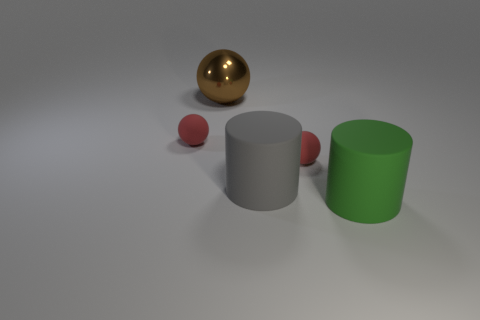What shape is the thing that is both left of the gray cylinder and in front of the brown metallic ball?
Ensure brevity in your answer.  Sphere. What is the material of the small object that is left of the big cylinder that is on the left side of the big green rubber cylinder?
Offer a very short reply. Rubber. Are the tiny object to the right of the metal thing and the big brown ball made of the same material?
Give a very brief answer. No. How big is the red thing right of the large brown sphere?
Your answer should be compact. Small. There is a red sphere to the left of the large brown metal object; are there any tiny balls that are on the right side of it?
Offer a very short reply. Yes. Is the color of the small rubber ball that is left of the gray rubber thing the same as the matte ball right of the brown sphere?
Keep it short and to the point. Yes. What color is the big ball?
Offer a very short reply. Brown. Is there anything else of the same color as the large ball?
Your answer should be very brief. No. There is a matte thing that is both to the right of the gray rubber cylinder and behind the gray cylinder; what is its color?
Make the answer very short. Red. There is a rubber cylinder that is in front of the gray cylinder; does it have the same size as the large sphere?
Your answer should be compact. Yes. 